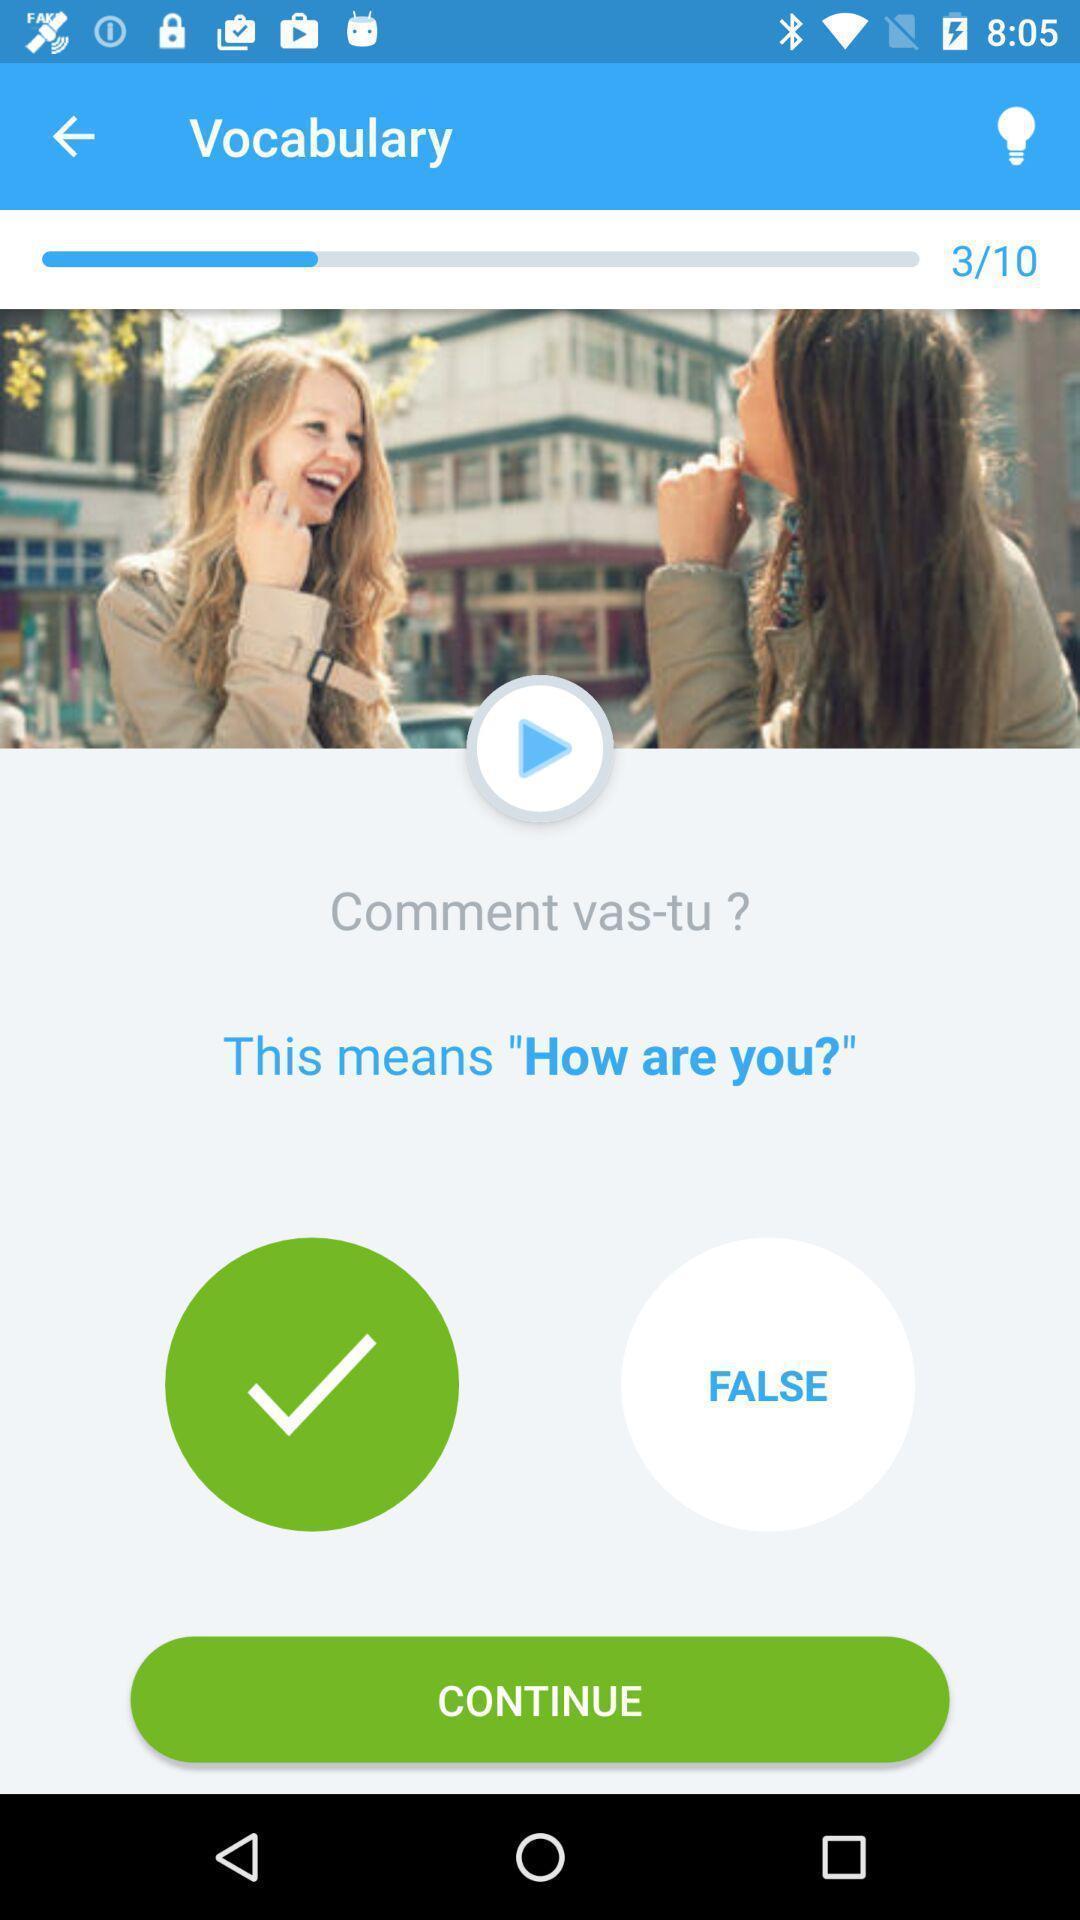Tell me about the visual elements in this screen capture. Vocabulary learning page displayed in language leaning app. 